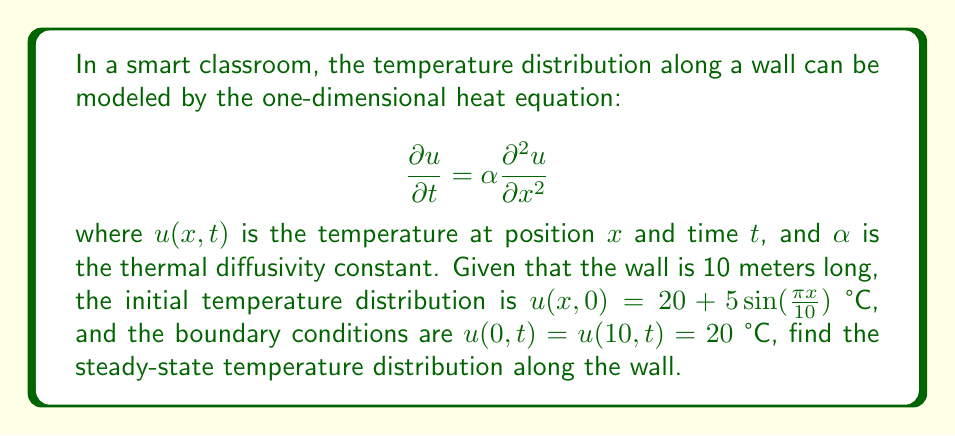Help me with this question. To solve this problem, we need to follow these steps:

1) The steady-state solution is independent of time, so we set $\frac{\partial u}{\partial t} = 0$ in the heat equation:

   $$0 = \alpha \frac{d^2 u}{dx^2}$$

2) This simplifies to:

   $$\frac{d^2 u}{dx^2} = 0$$

3) The general solution to this equation is:

   $$u(x) = Ax + B$$

   where $A$ and $B$ are constants to be determined.

4) We use the boundary conditions to find $A$ and $B$:

   At $x = 0$: $u(0) = B = 20$
   At $x = 10$: $u(10) = 10A + 20 = 20$

5) From the second condition:

   $$10A + 20 = 20$$
   $$10A = 0$$
   $$A = 0$$

6) Therefore, the steady-state solution is:

   $$u(x) = 20$$

This means that regardless of the initial temperature distribution, the steady-state temperature along the wall will be uniformly 20°C.
Answer: $u(x) = 20$ °C 